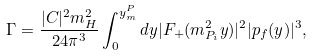<formula> <loc_0><loc_0><loc_500><loc_500>\Gamma = \frac { | C | ^ { 2 } m _ { H } ^ { 2 } } { 2 4 \pi ^ { 3 } } \int _ { 0 } ^ { y _ { m } ^ { P } } d y | F _ { + } ( m _ { P _ { i } } ^ { 2 } y ) | ^ { 2 } | { p } _ { f } ( y ) | ^ { 3 } ,</formula> 